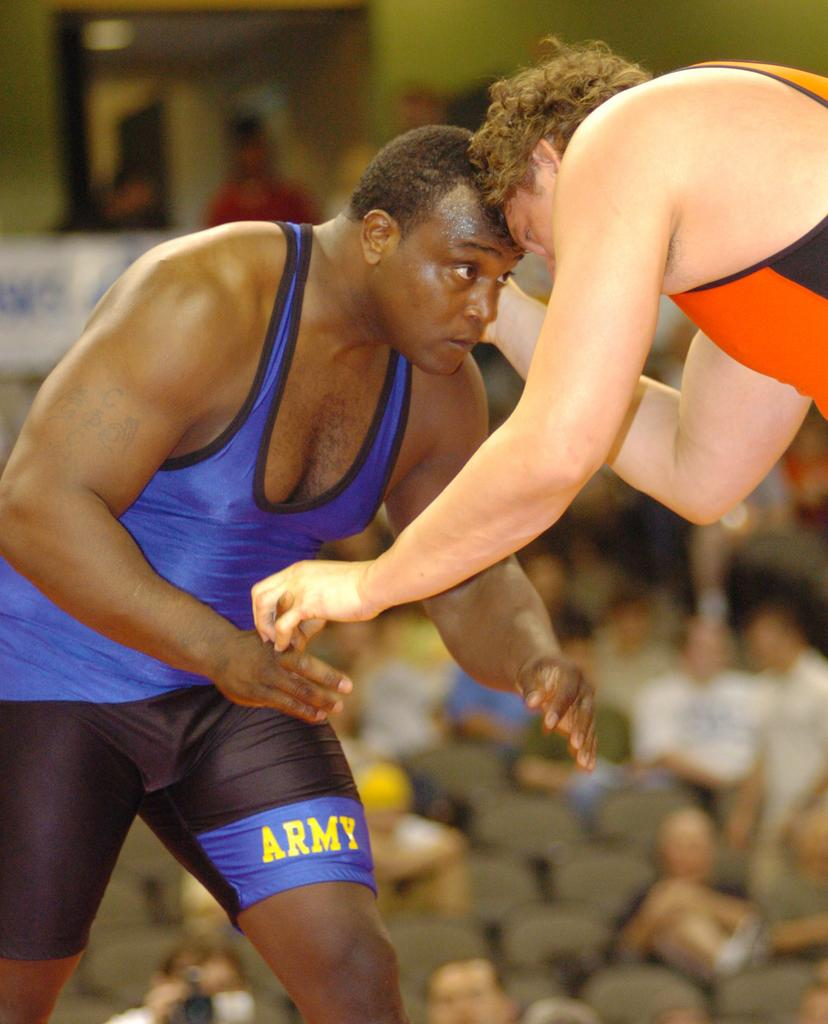<image>
Provide a brief description of the given image. Two wrestlers are wrestling in front of a crowd, one is wearing black and blue with ARMY imprinted on the leg and the other is in orange and black. 